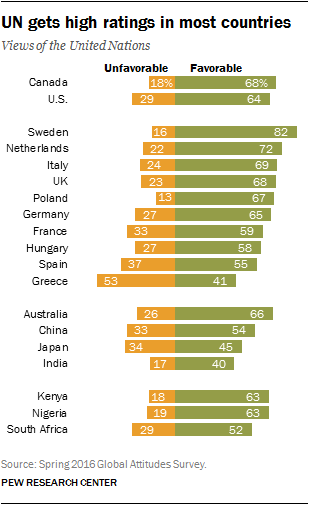Outline some significant characteristics in this image. The sum of two green bars with the same values is 126. According to the data, the unfavorable opinion in Canada is 0.18. 